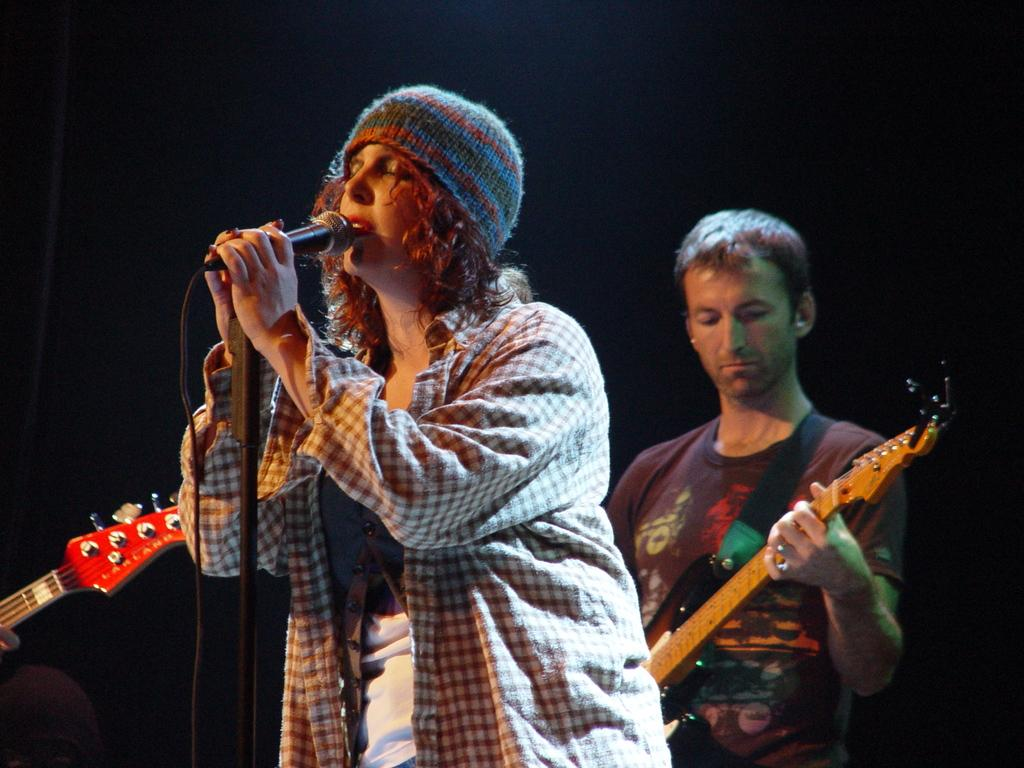Who is the main subject in the image? There is a woman in the image. Where is the woman positioned in the image? The woman is standing in the center. What is the woman doing in the image? The woman is singing on a microphone. Can you describe the person in the background of the image? There is a person in the background of the image, and they are standing on the left side. What is the person in the background doing? The person in the background is playing a guitar. Where is the nest located in the image? There is no nest present in the image. How many boys are visible in the image? There is no mention of boys in the image; it features a woman singing and a person playing a guitar. 